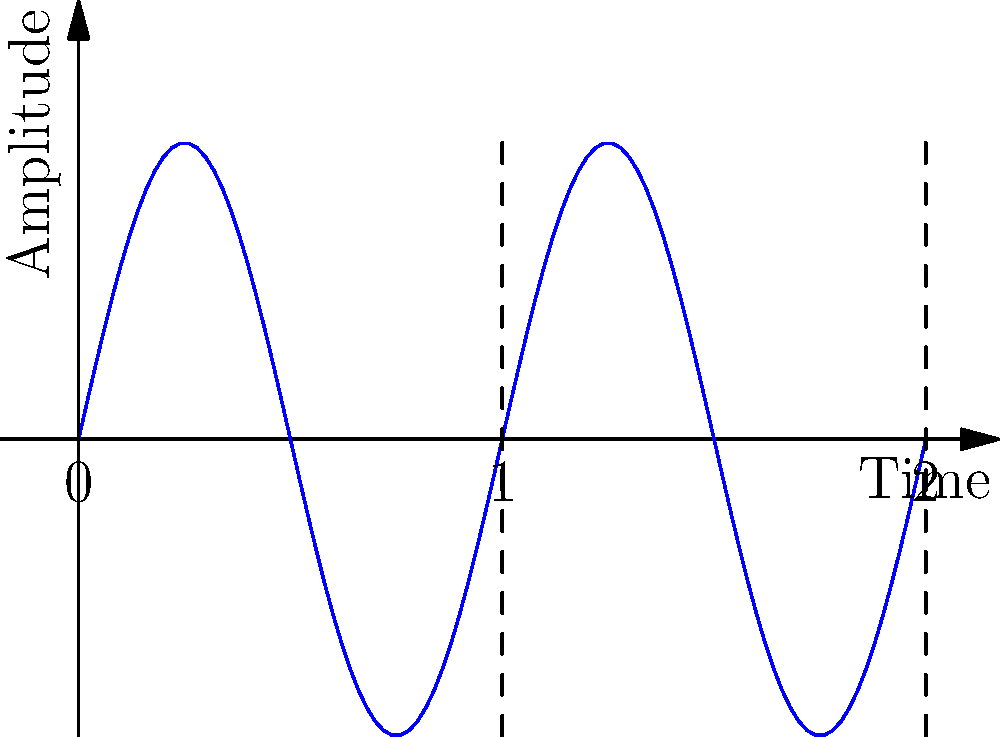Looking at this audio waveform on an oscilloscope, what can you tell me about the frequency of this signal if each horizontal division represents 0.5 milliseconds? To determine the frequency of the signal, we need to follow these steps:

1. Identify one complete cycle of the waveform. In this case, we can see that one full cycle occurs between 0 and 1 on the horizontal axis.

2. Determine the time period (T) of one cycle. We're told that each horizontal division represents 0.5 milliseconds (ms). Since one cycle spans 2 divisions:
   $T = 2 \times 0.5\text{ ms} = 1\text{ ms} = 0.001\text{ seconds}$

3. Calculate the frequency using the formula: $f = \frac{1}{T}$
   $f = \frac{1}{0.001\text{ s}} = 1000\text{ Hz}$

Therefore, the frequency of this audio signal is 1000 Hz or 1 kHz.
Answer: 1 kHz 